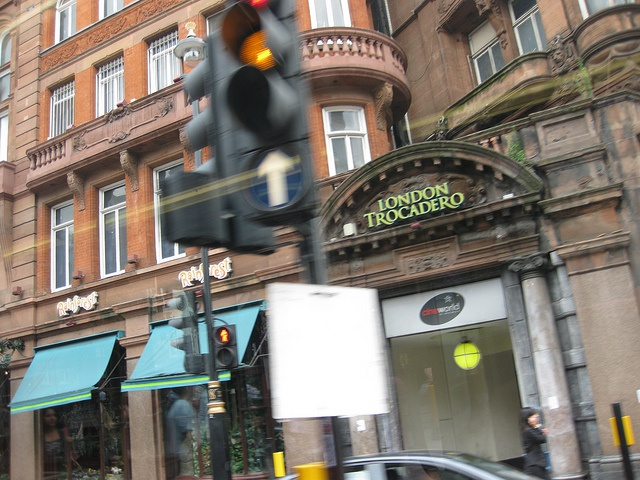Describe the objects in this image and their specific colors. I can see traffic light in gray, black, darkgray, and blue tones, car in gray, darkgray, lightgray, and black tones, traffic light in gray, darkgray, black, and purple tones, people in gray, black, and tan tones, and traffic light in gray, black, lightblue, and purple tones in this image. 